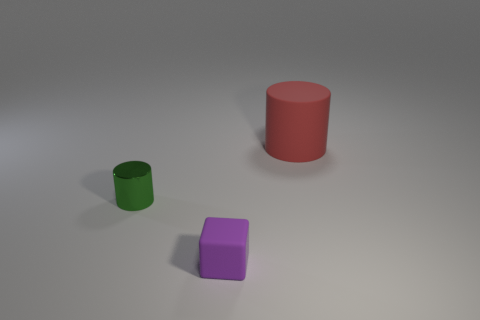Subtract all red cylinders. How many cylinders are left? 1 Subtract 1 cylinders. How many cylinders are left? 1 Add 3 large red cylinders. How many large red cylinders are left? 4 Add 3 large green rubber balls. How many large green rubber balls exist? 3 Add 3 tiny purple matte blocks. How many objects exist? 6 Subtract 0 green blocks. How many objects are left? 3 Subtract all cylinders. How many objects are left? 1 Subtract all purple cylinders. Subtract all green cubes. How many cylinders are left? 2 Subtract all red spheres. How many green blocks are left? 0 Subtract all tiny purple rubber blocks. Subtract all red rubber cylinders. How many objects are left? 1 